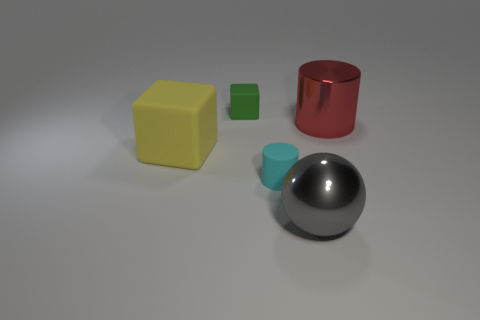Add 1 small purple metallic blocks. How many objects exist? 6 Subtract all balls. How many objects are left? 4 Add 4 big yellow objects. How many big yellow objects are left? 5 Add 5 small cylinders. How many small cylinders exist? 6 Subtract 0 purple cylinders. How many objects are left? 5 Subtract all big red shiny objects. Subtract all large metallic objects. How many objects are left? 2 